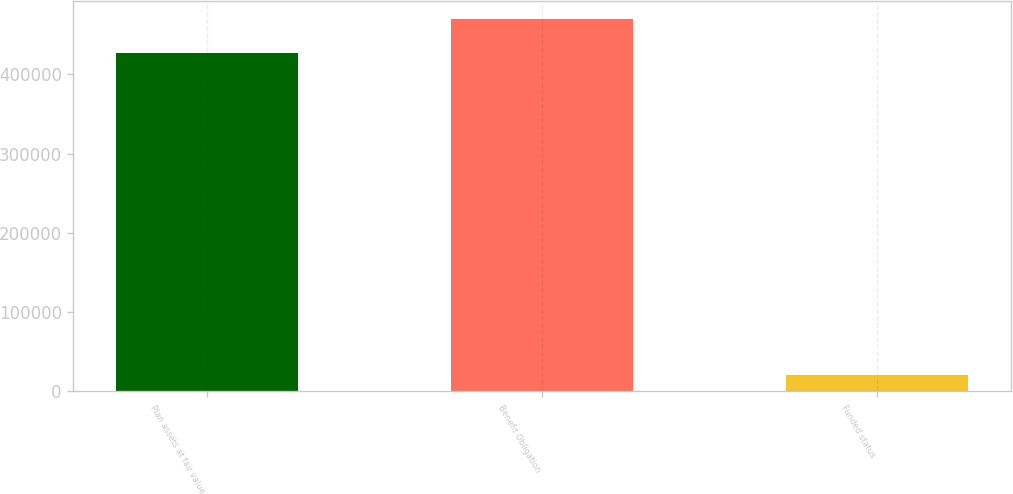Convert chart to OTSL. <chart><loc_0><loc_0><loc_500><loc_500><bar_chart><fcel>Plan assets at fair value<fcel>Benefit Obligation<fcel>Funded status<nl><fcel>426784<fcel>469462<fcel>20768<nl></chart> 